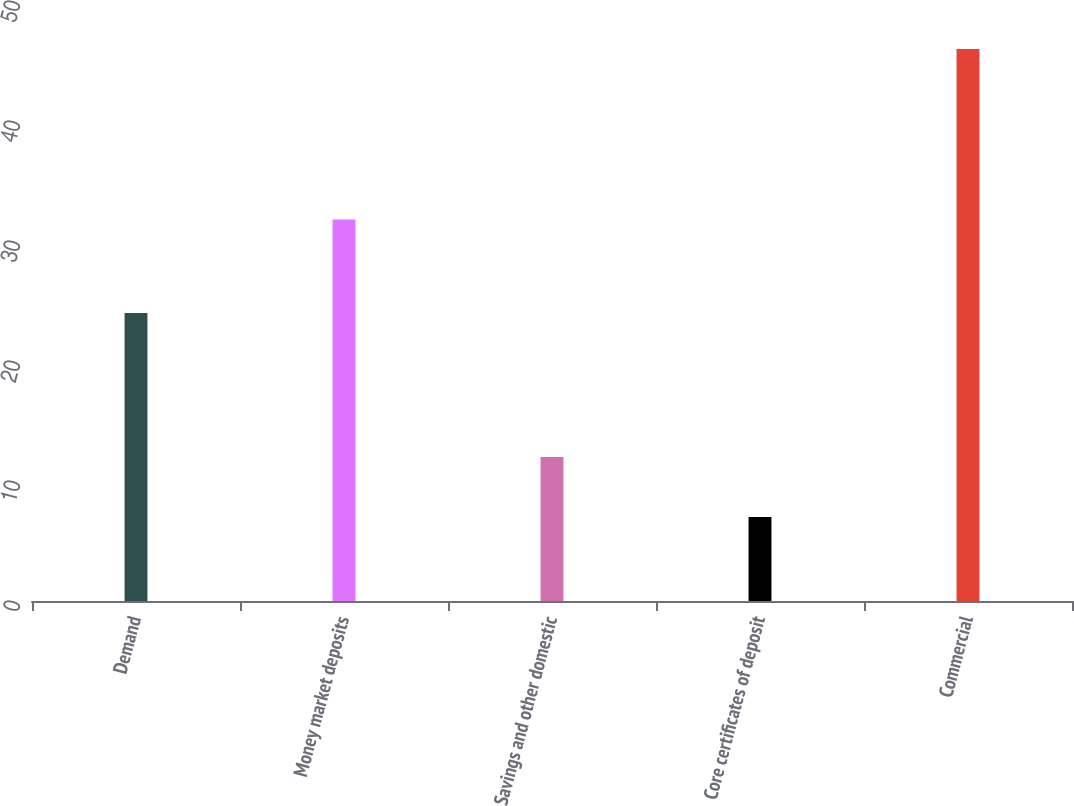Convert chart to OTSL. <chart><loc_0><loc_0><loc_500><loc_500><bar_chart><fcel>Demand<fcel>Money market deposits<fcel>Savings and other domestic<fcel>Core certificates of deposit<fcel>Commercial<nl><fcel>24<fcel>31.8<fcel>12<fcel>7<fcel>46<nl></chart> 